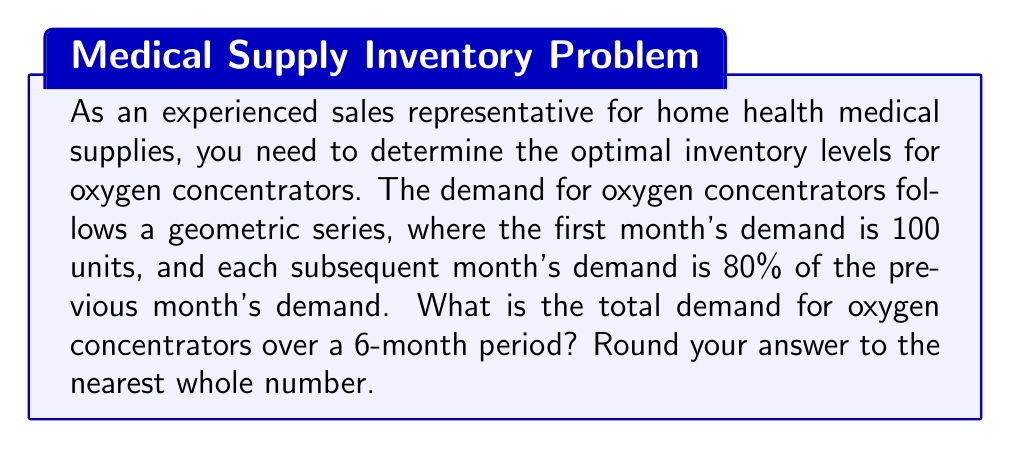Show me your answer to this math problem. To solve this problem, we need to use the formula for the sum of a geometric series:

$$S_n = \frac{a(1-r^n)}{1-r}$$

Where:
$S_n$ = Sum of the series
$a$ = First term
$r$ = Common ratio
$n$ = Number of terms

Given:
$a = 100$ (first month's demand)
$r = 0.8$ (each month's demand is 80% of the previous month)
$n = 6$ (6-month period)

Let's substitute these values into the formula:

$$S_6 = \frac{100(1-0.8^6)}{1-0.8}$$

$$S_6 = \frac{100(1-0.262144)}{0.2}$$

$$S_6 = \frac{100(0.737856)}{0.2}$$

$$S_6 = 368.928$$

Rounding to the nearest whole number:

$$S_6 \approx 369$$
Answer: 369 oxygen concentrators 